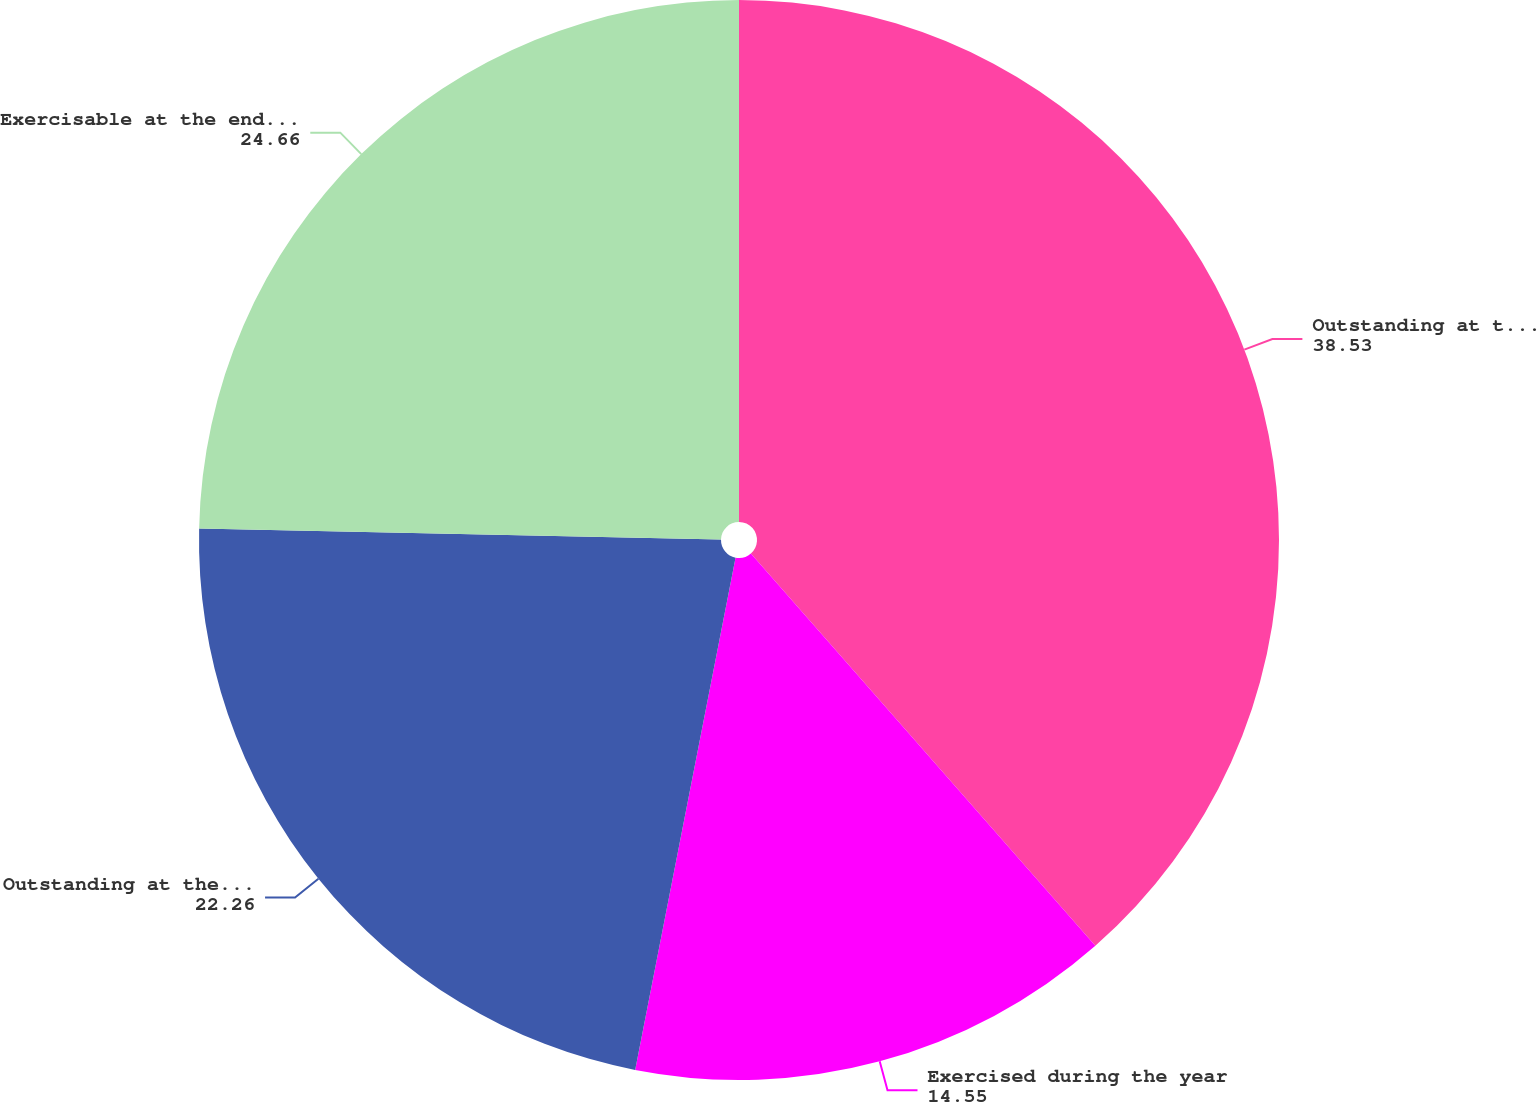<chart> <loc_0><loc_0><loc_500><loc_500><pie_chart><fcel>Outstanding at the beginning<fcel>Exercised during the year<fcel>Outstanding at the end of the<fcel>Exercisable at the end of the<nl><fcel>38.53%<fcel>14.55%<fcel>22.26%<fcel>24.66%<nl></chart> 